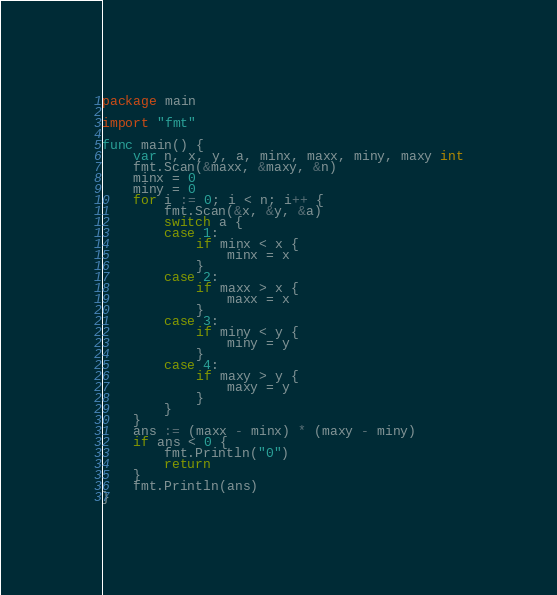<code> <loc_0><loc_0><loc_500><loc_500><_Go_>package main

import "fmt"

func main() {
	var n, x, y, a, minx, maxx, miny, maxy int
	fmt.Scan(&maxx, &maxy, &n)
	minx = 0
	miny = 0
	for i := 0; i < n; i++ {
		fmt.Scan(&x, &y, &a)
		switch a {
		case 1:
			if minx < x {
				minx = x
			}
		case 2:
			if maxx > x {
				maxx = x
			}
		case 3:
			if miny < y {
				miny = y
			}
		case 4:
			if maxy > y {
				maxy = y
			}
		}
	}
	ans := (maxx - minx) * (maxy - miny)
	if ans < 0 {
		fmt.Println("0")
		return
	}
	fmt.Println(ans)
}</code> 